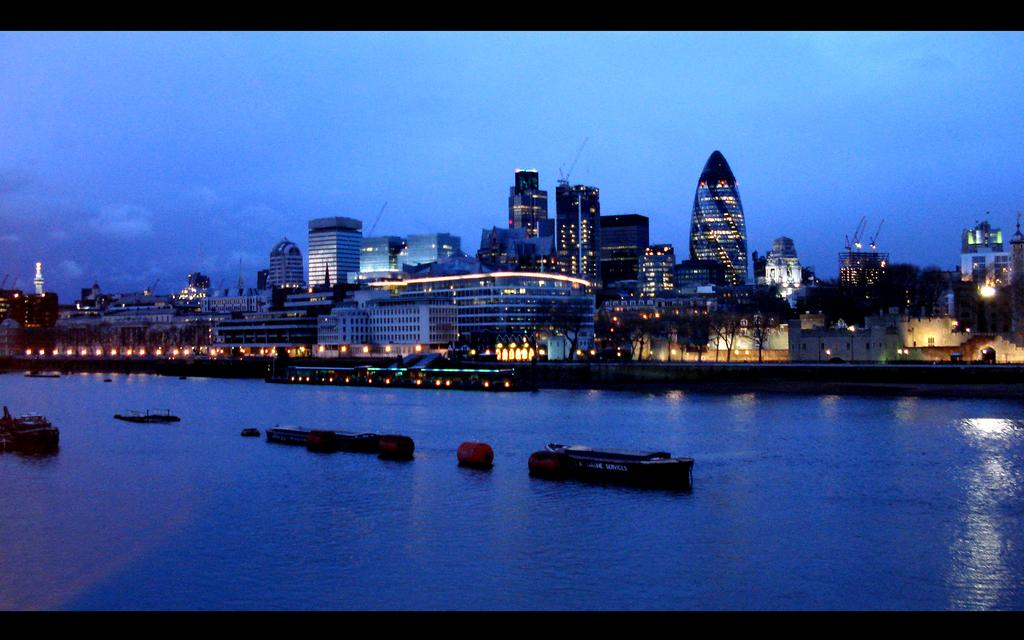What can be seen floating on the water in the image? There are boats in the image. What else is present on the surface of the water? There are objects on the surface of the water. What can be seen in the distance in the image? There are lights, trees, buildings, and the sky visible in the background. What emotion is the hand expressing in the image? There is no hand present in the image, so it is not possible to determine the emotion it might be expressing. 